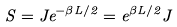<formula> <loc_0><loc_0><loc_500><loc_500>S = J e ^ { - \beta L / 2 } = e ^ { \beta L / 2 } J</formula> 